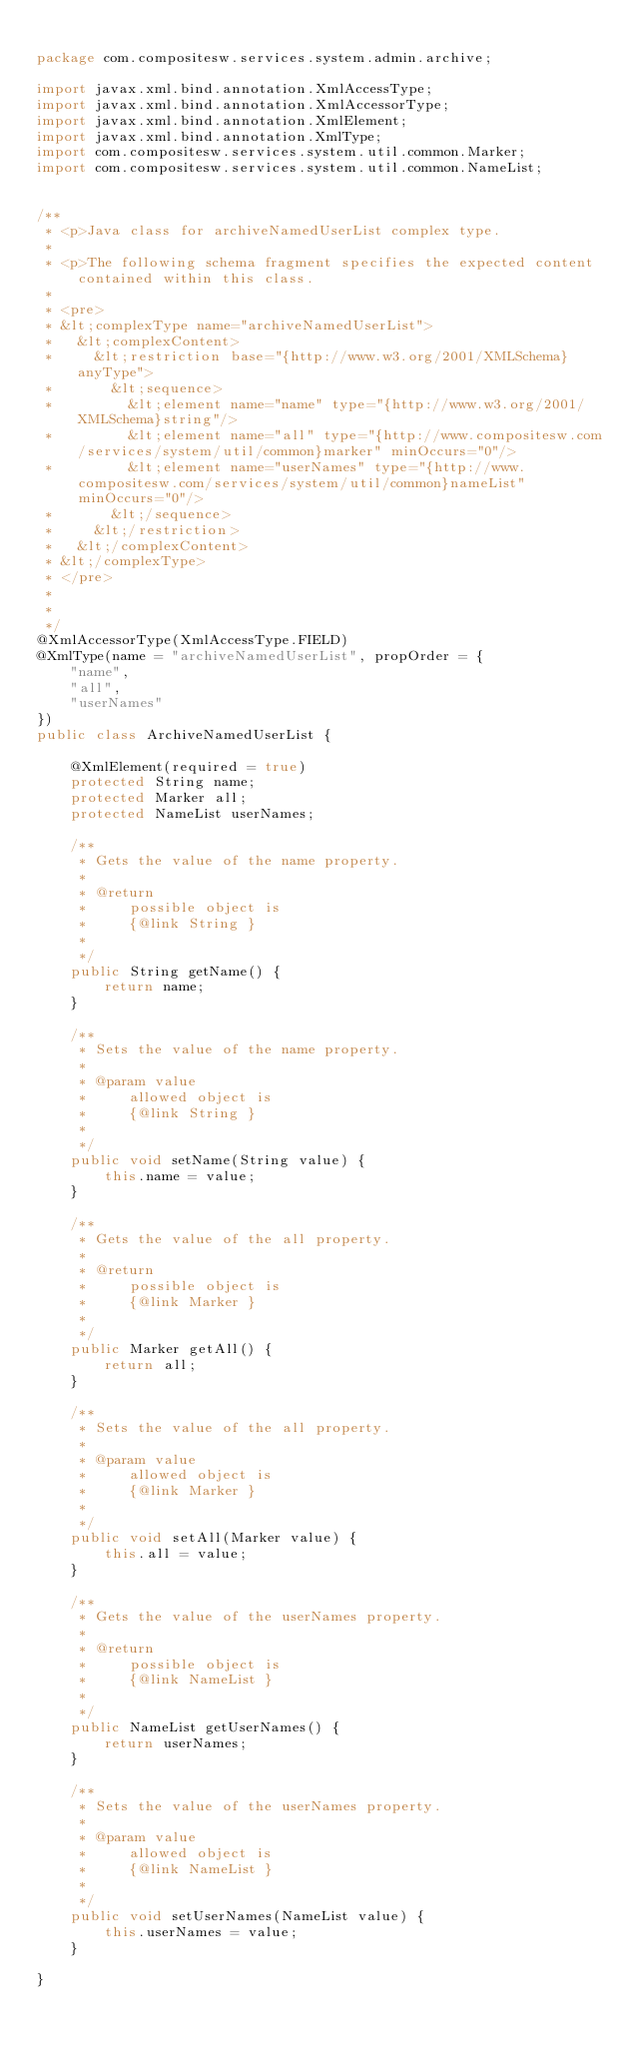Convert code to text. <code><loc_0><loc_0><loc_500><loc_500><_Java_>
package com.compositesw.services.system.admin.archive;

import javax.xml.bind.annotation.XmlAccessType;
import javax.xml.bind.annotation.XmlAccessorType;
import javax.xml.bind.annotation.XmlElement;
import javax.xml.bind.annotation.XmlType;
import com.compositesw.services.system.util.common.Marker;
import com.compositesw.services.system.util.common.NameList;


/**
 * <p>Java class for archiveNamedUserList complex type.
 * 
 * <p>The following schema fragment specifies the expected content contained within this class.
 * 
 * <pre>
 * &lt;complexType name="archiveNamedUserList">
 *   &lt;complexContent>
 *     &lt;restriction base="{http://www.w3.org/2001/XMLSchema}anyType">
 *       &lt;sequence>
 *         &lt;element name="name" type="{http://www.w3.org/2001/XMLSchema}string"/>
 *         &lt;element name="all" type="{http://www.compositesw.com/services/system/util/common}marker" minOccurs="0"/>
 *         &lt;element name="userNames" type="{http://www.compositesw.com/services/system/util/common}nameList" minOccurs="0"/>
 *       &lt;/sequence>
 *     &lt;/restriction>
 *   &lt;/complexContent>
 * &lt;/complexType>
 * </pre>
 * 
 * 
 */
@XmlAccessorType(XmlAccessType.FIELD)
@XmlType(name = "archiveNamedUserList", propOrder = {
    "name",
    "all",
    "userNames"
})
public class ArchiveNamedUserList {

    @XmlElement(required = true)
    protected String name;
    protected Marker all;
    protected NameList userNames;

    /**
     * Gets the value of the name property.
     * 
     * @return
     *     possible object is
     *     {@link String }
     *     
     */
    public String getName() {
        return name;
    }

    /**
     * Sets the value of the name property.
     * 
     * @param value
     *     allowed object is
     *     {@link String }
     *     
     */
    public void setName(String value) {
        this.name = value;
    }

    /**
     * Gets the value of the all property.
     * 
     * @return
     *     possible object is
     *     {@link Marker }
     *     
     */
    public Marker getAll() {
        return all;
    }

    /**
     * Sets the value of the all property.
     * 
     * @param value
     *     allowed object is
     *     {@link Marker }
     *     
     */
    public void setAll(Marker value) {
        this.all = value;
    }

    /**
     * Gets the value of the userNames property.
     * 
     * @return
     *     possible object is
     *     {@link NameList }
     *     
     */
    public NameList getUserNames() {
        return userNames;
    }

    /**
     * Sets the value of the userNames property.
     * 
     * @param value
     *     allowed object is
     *     {@link NameList }
     *     
     */
    public void setUserNames(NameList value) {
        this.userNames = value;
    }

}
</code> 